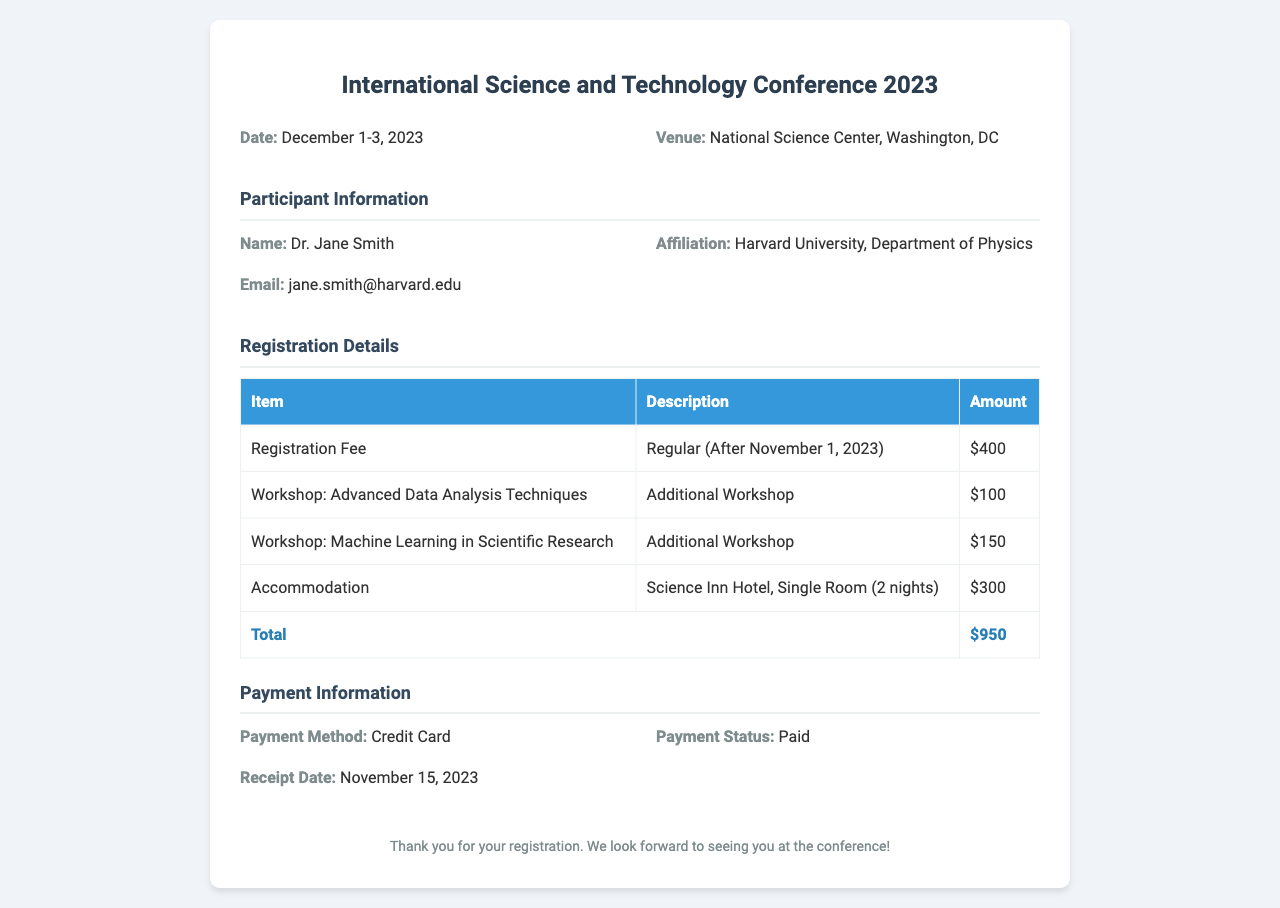what is the name of the participant? The participant's name is clearly stated in the document under "Participant Information."
Answer: Dr. Jane Smith what is the registration fee? The registration fee is listed in the "Registration Details" section of the document.
Answer: $400 how many workshops did the participant select? The document outlines two workshops selected under "Registration Details."
Answer: 2 what is the total amount due? The total amount appears at the end of the "Registration Details" table and sums all fees.
Answer: $950 what is the venue of the conference? The venue is specified in the initial information section of the document.
Answer: National Science Center, Washington, DC what is the receipt date? The receipt date is mentioned under "Payment Information" in the document.
Answer: November 15, 2023 what accommodation was selected? The document mentions the selected accommodation in the "Registration Details" section.
Answer: Science Inn Hotel, Single Room (2 nights) what type of payment was used? The payment method is detailed in the "Payment Information" area of the document.
Answer: Credit Card what are the dates of the conference? The conference dates are listed prominently at the beginning of the document.
Answer: December 1-3, 2023 